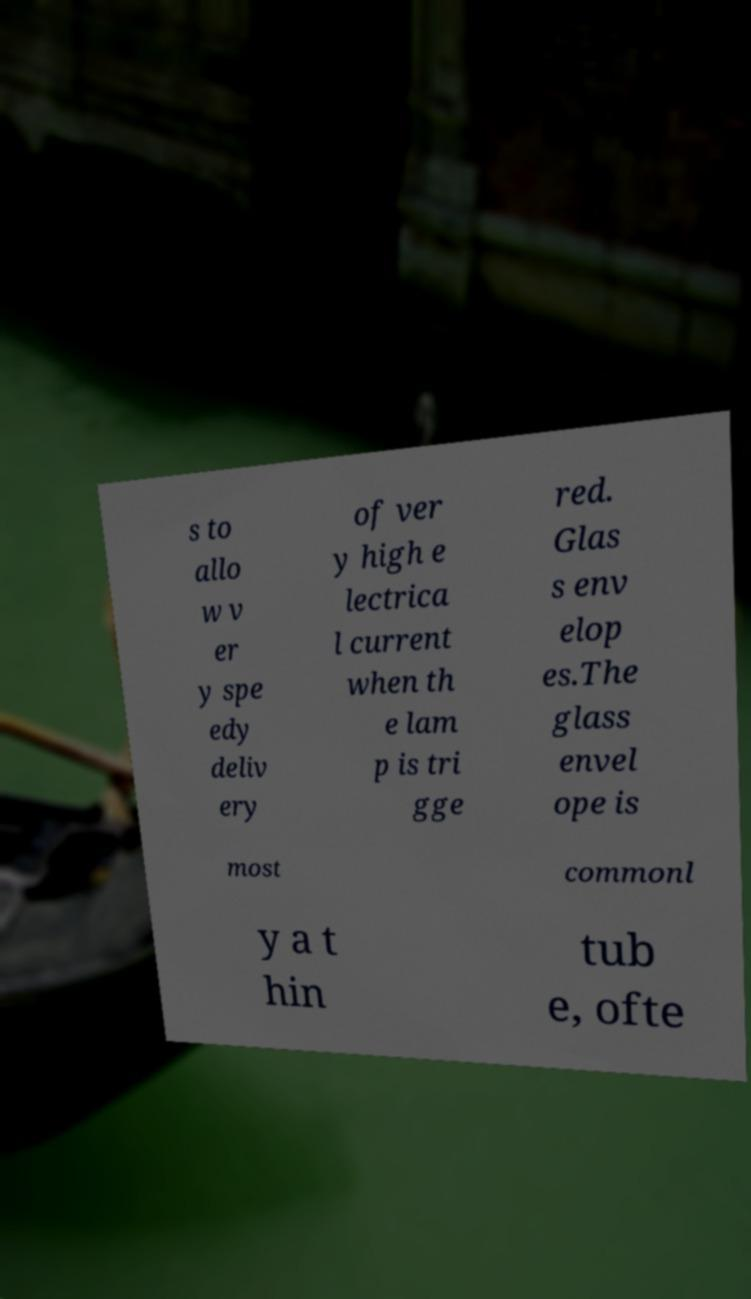I need the written content from this picture converted into text. Can you do that? s to allo w v er y spe edy deliv ery of ver y high e lectrica l current when th e lam p is tri gge red. Glas s env elop es.The glass envel ope is most commonl y a t hin tub e, ofte 